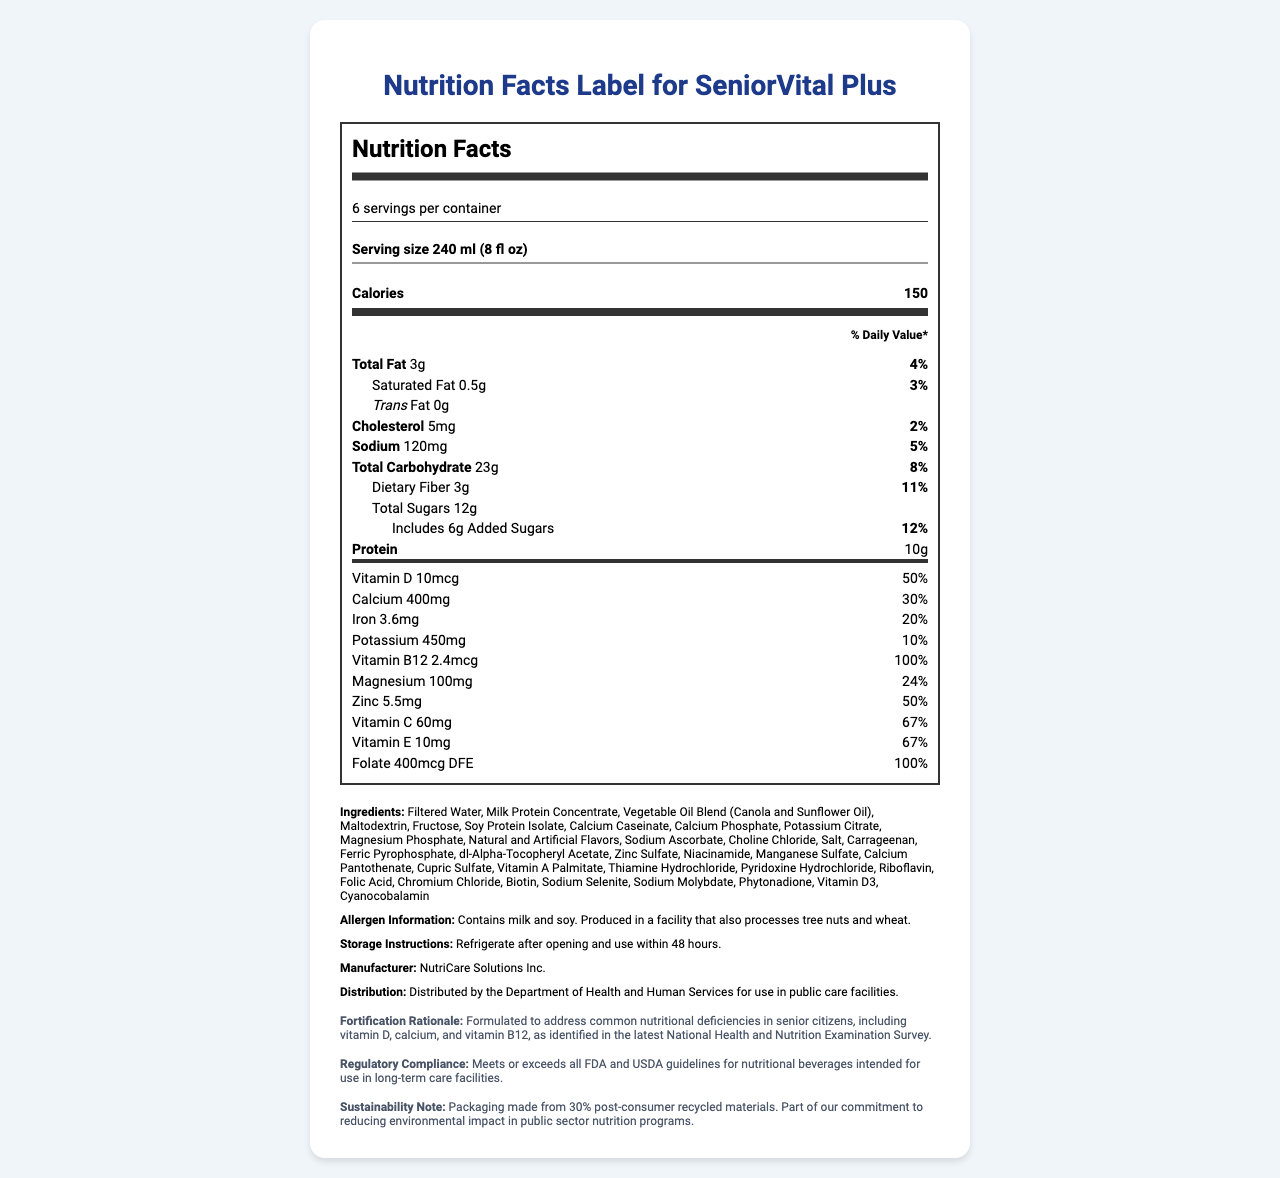what is the serving size of SeniorVital Plus? The serving size is listed at the top of the Nutrition Facts label.
Answer: 240 ml (8 fl oz) how many total calories are in one serving? The total calories per serving are shown in a bold font.
Answer: 150 what is the percentage daily value of vitamin D? The percentage daily value for vitamin D can be found under the vitamins section.
Answer: 50% which ingredient appears first in the ingredient list? The ingredients are listed in the ingredients section, with Filtered Water being the first.
Answer: Filtered Water does this product contain any trans fat? The label specifically states that the trans fat amount is 0g.
Answer: No how many grams of dietary fiber does one serving provide? Dietary fiber information is listed under the total carbohydrate section.
Answer: 3g what is the daily value percentage of calcium? A. 20% B. 30% C. 50% D. 67% The daily value for calcium is shown as 30%.
Answer: B which of the following vitamins or minerals has the highest daily value percentage in one serving? A. Vitamin C B. Iron C. Folate D. Magnesium Folate has a daily value percentage of 100%, the highest among the listed options.
Answer: C does the product contain allergens? The allergen information specifies that the product contains milk and soy.
Answer: Yes is the SeniorVital Plus fortified to address common nutritional deficiencies? The fortification rationale explains that the product is formulated to address common nutritional deficiencies in senior citizens.
Answer: Yes summarize the main purpose of the SeniorVital Plus beverage. The summary highlights the product's goal to meet senior citizens' nutritional needs, its compliance with regulations, and its sustainability efforts.
Answer: SeniorVital Plus is a fortified beverage designed to meet the nutritional needs of senior citizens in public care facilities. It provides essential vitamins and minerals, addresses common nutritional deficiencies, and complies with FDA and USDA guidelines. The product also focuses on sustainability with packaging made from recycled materials. what is the manufacturer of SeniorVital Plus? The manufacturer's name is found in the manufacturer section of the document.
Answer: NutriCare Solutions Inc. how should the product be stored after opening? Storage instructions are provided in the storage section.
Answer: Refrigerate and use within 48 hours what is the total amount of added sugars in one serving? Added sugars are listed under the total sugars in the carbohydrate section.
Answer: 6g how many servings are there in one container? The number of servings per container is found in the serving info section.
Answer: 6 what type of oil is used in the ingredients? The Vegetable Oil Blend includes Canola and Sunflower Oil as mentioned in the ingredients list.
Answer: Canola and Sunflower Oil how much protein is in each serving? The amount of protein per serving is listed under the main nutrient information.
Answer: 10g what kind of flavorings are included in the ingredients? The ingredients list mentions Natural and Artificial Flavors.
Answer: Natural and Artificial Flavors does SeniorVital Plus contain any vitamins from the vitamin B group? The label lists Vitamin B12 and several B vitamins in different forms such as Riboflavin (B2), and Thiamine Hydrochloride (B1).
Answer: Yes are there any environmental considerations mentioned regarding the product? The sustainability note mentions that the packaging is made from 30% post-consumer recycled materials.
Answer: Yes what is the exact percentage of daily value for saturated fat? The daily value percentage for saturated fat is listed under the total fat section.
Answer: 3% why was SeniorVital Plus formulated according to the document? The fortification rationale provides the reason for formulation.
Answer: To address common nutritional deficiencies in senior citizens as identified in the National Health and Nutrition Examination Survey what does "% Daily Value*" mean on the nutrition label? The document does not explain what "% Daily Value*" means.
Answer: Not enough information how much magnesium is in one serving and what is its daily value percentage? The magnesium amount and its daily value percentage are both listed under the vitamins section.
Answer: 100mg, 24% 